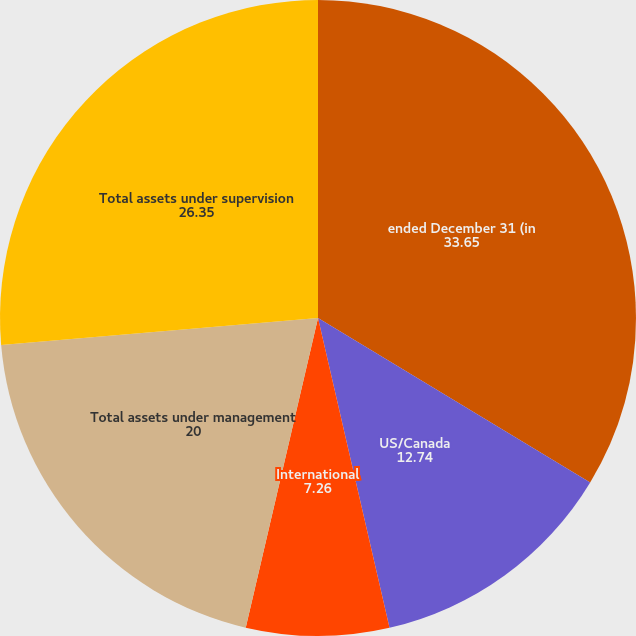<chart> <loc_0><loc_0><loc_500><loc_500><pie_chart><fcel>ended December 31 (in<fcel>US/Canada<fcel>International<fcel>Total assets under management<fcel>Total assets under supervision<nl><fcel>33.65%<fcel>12.74%<fcel>7.26%<fcel>20.0%<fcel>26.35%<nl></chart> 